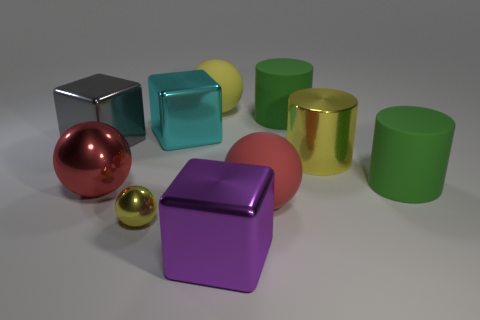Subtract all balls. How many objects are left? 6 Add 5 cylinders. How many cylinders are left? 8 Add 4 tiny yellow matte cylinders. How many tiny yellow matte cylinders exist? 4 Subtract all cyan blocks. How many blocks are left? 2 Subtract all yellow shiny cylinders. How many cylinders are left? 2 Subtract 1 yellow balls. How many objects are left? 9 Subtract 1 cubes. How many cubes are left? 2 Subtract all red balls. Subtract all blue cubes. How many balls are left? 2 Subtract all cyan cylinders. How many red cubes are left? 0 Subtract all small blue matte cubes. Subtract all big rubber balls. How many objects are left? 8 